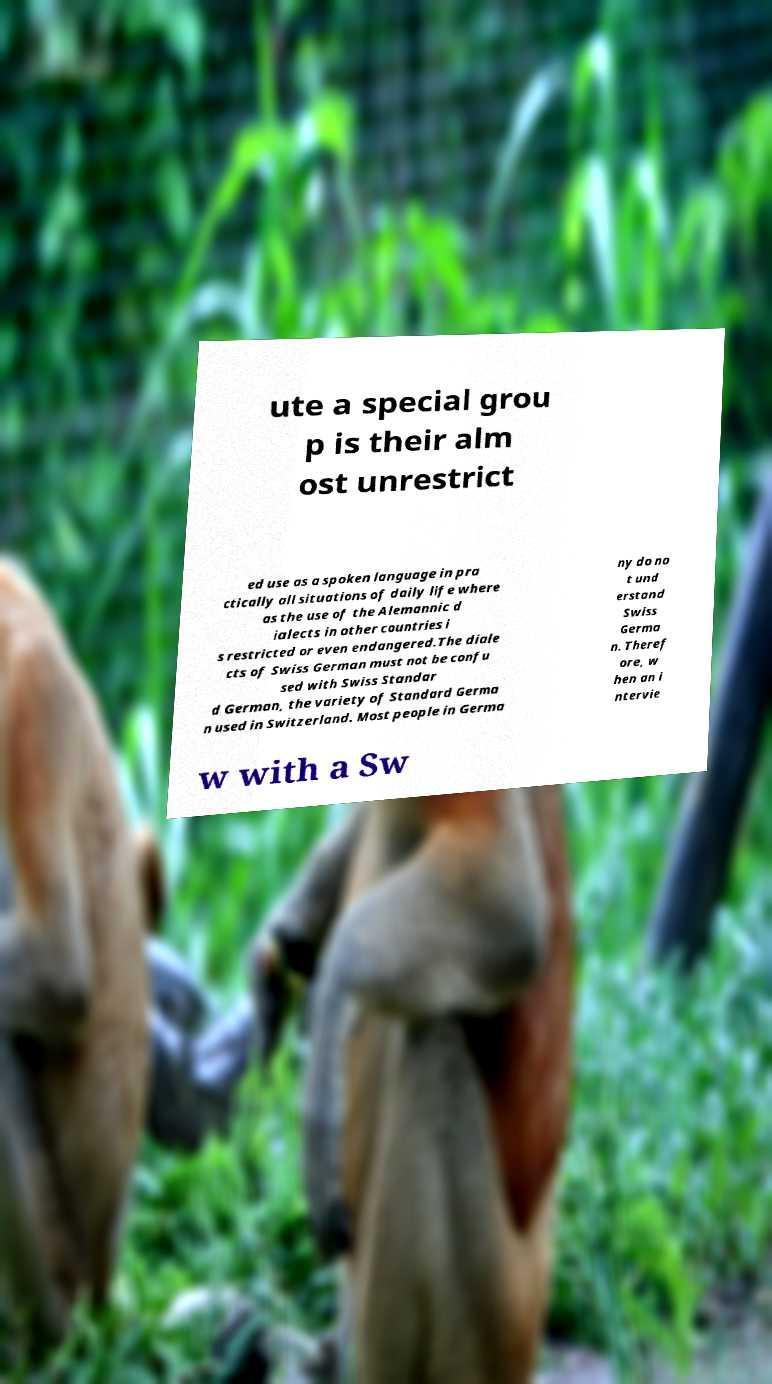Can you accurately transcribe the text from the provided image for me? ute a special grou p is their alm ost unrestrict ed use as a spoken language in pra ctically all situations of daily life where as the use of the Alemannic d ialects in other countries i s restricted or even endangered.The diale cts of Swiss German must not be confu sed with Swiss Standar d German, the variety of Standard Germa n used in Switzerland. Most people in Germa ny do no t und erstand Swiss Germa n. Theref ore, w hen an i ntervie w with a Sw 